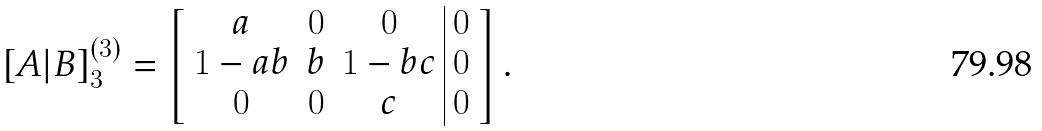<formula> <loc_0><loc_0><loc_500><loc_500>[ A | B ] _ { 3 } ^ { ( 3 ) } = \left [ \begin{array} { c c c | c } a & 0 & 0 & 0 \\ 1 - a b & b & 1 - b c & 0 \\ 0 & 0 & c & 0 \end{array} \right ] .</formula> 